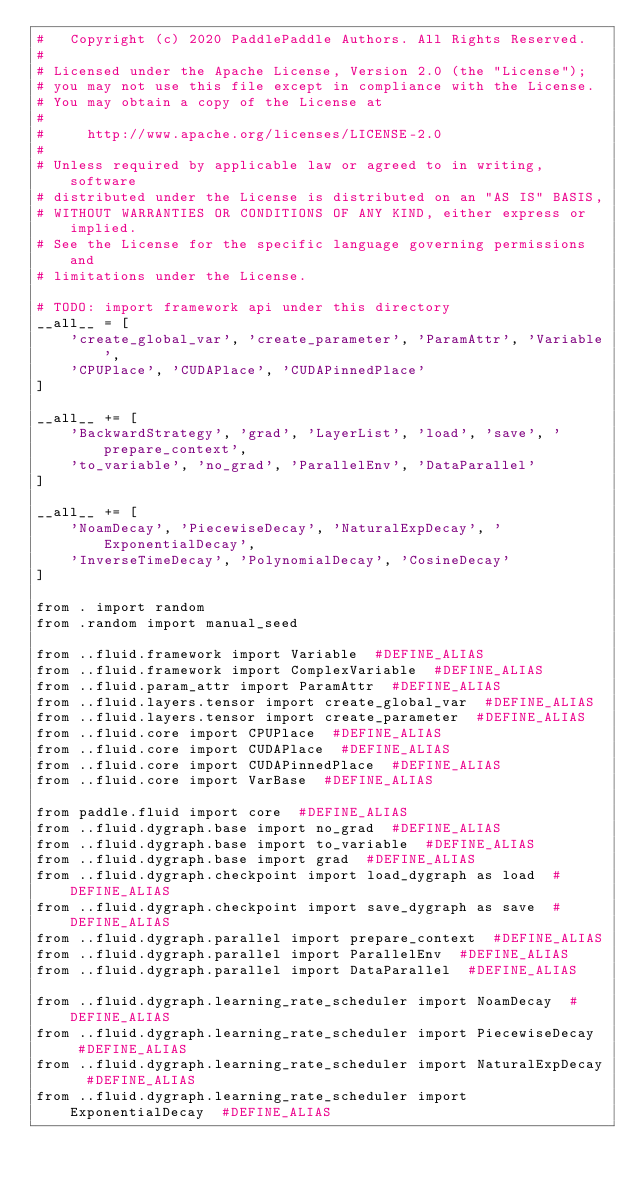Convert code to text. <code><loc_0><loc_0><loc_500><loc_500><_Python_>#   Copyright (c) 2020 PaddlePaddle Authors. All Rights Reserved.
#
# Licensed under the Apache License, Version 2.0 (the "License");
# you may not use this file except in compliance with the License.
# You may obtain a copy of the License at
#
#     http://www.apache.org/licenses/LICENSE-2.0
#
# Unless required by applicable law or agreed to in writing, software
# distributed under the License is distributed on an "AS IS" BASIS,
# WITHOUT WARRANTIES OR CONDITIONS OF ANY KIND, either express or implied.
# See the License for the specific language governing permissions and
# limitations under the License.

# TODO: import framework api under this directory 
__all__ = [
    'create_global_var', 'create_parameter', 'ParamAttr', 'Variable',
    'CPUPlace', 'CUDAPlace', 'CUDAPinnedPlace'
]

__all__ += [
    'BackwardStrategy', 'grad', 'LayerList', 'load', 'save', 'prepare_context',
    'to_variable', 'no_grad', 'ParallelEnv', 'DataParallel'
]

__all__ += [
    'NoamDecay', 'PiecewiseDecay', 'NaturalExpDecay', 'ExponentialDecay',
    'InverseTimeDecay', 'PolynomialDecay', 'CosineDecay'
]

from . import random
from .random import manual_seed

from ..fluid.framework import Variable  #DEFINE_ALIAS
from ..fluid.framework import ComplexVariable  #DEFINE_ALIAS
from ..fluid.param_attr import ParamAttr  #DEFINE_ALIAS
from ..fluid.layers.tensor import create_global_var  #DEFINE_ALIAS
from ..fluid.layers.tensor import create_parameter  #DEFINE_ALIAS
from ..fluid.core import CPUPlace  #DEFINE_ALIAS
from ..fluid.core import CUDAPlace  #DEFINE_ALIAS
from ..fluid.core import CUDAPinnedPlace  #DEFINE_ALIAS
from ..fluid.core import VarBase  #DEFINE_ALIAS

from paddle.fluid import core  #DEFINE_ALIAS
from ..fluid.dygraph.base import no_grad  #DEFINE_ALIAS
from ..fluid.dygraph.base import to_variable  #DEFINE_ALIAS
from ..fluid.dygraph.base import grad  #DEFINE_ALIAS
from ..fluid.dygraph.checkpoint import load_dygraph as load  #DEFINE_ALIAS
from ..fluid.dygraph.checkpoint import save_dygraph as save  #DEFINE_ALIAS
from ..fluid.dygraph.parallel import prepare_context  #DEFINE_ALIAS
from ..fluid.dygraph.parallel import ParallelEnv  #DEFINE_ALIAS
from ..fluid.dygraph.parallel import DataParallel  #DEFINE_ALIAS

from ..fluid.dygraph.learning_rate_scheduler import NoamDecay  #DEFINE_ALIAS
from ..fluid.dygraph.learning_rate_scheduler import PiecewiseDecay  #DEFINE_ALIAS
from ..fluid.dygraph.learning_rate_scheduler import NaturalExpDecay  #DEFINE_ALIAS
from ..fluid.dygraph.learning_rate_scheduler import ExponentialDecay  #DEFINE_ALIAS</code> 